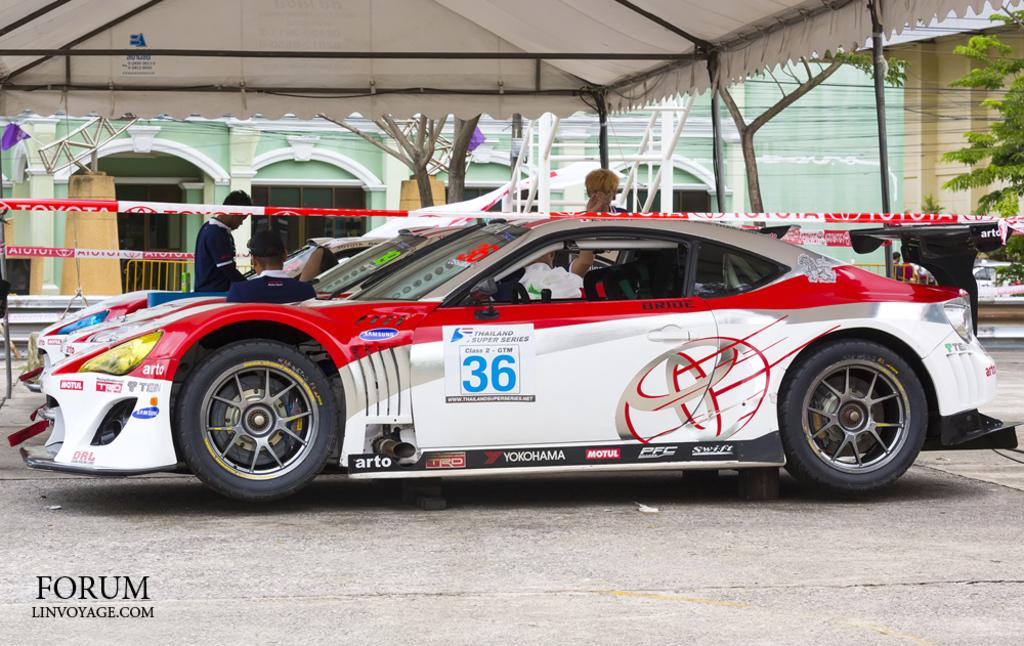What is the main subject of the image? The main subject of the image is cars parked at the center. Are there any people present in the image? Yes, there are people standing beside the parked cars. What can be seen in the background of the image? There is a building in the background of the image. What type of balloon is being used to inflate the tires of the parked cars? There is no balloon present in the image, and therefore no such activity can be observed. 